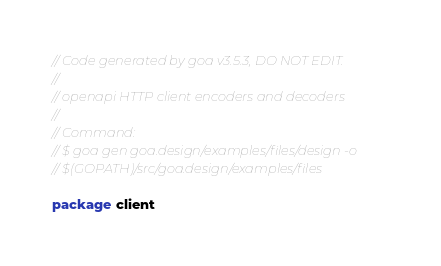<code> <loc_0><loc_0><loc_500><loc_500><_Go_>// Code generated by goa v3.5.3, DO NOT EDIT.
//
// openapi HTTP client encoders and decoders
//
// Command:
// $ goa gen goa.design/examples/files/design -o
// $(GOPATH)/src/goa.design/examples/files

package client
</code> 